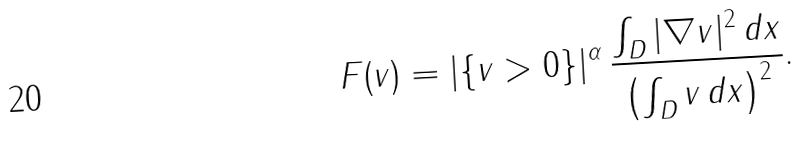<formula> <loc_0><loc_0><loc_500><loc_500>F ( v ) = | \{ v > 0 \} | ^ { \alpha } \, \frac { \int _ { D } | \nabla v | ^ { 2 } \, d x } { \left ( \int _ { D } v \, d x \right ) ^ { 2 } } .</formula> 